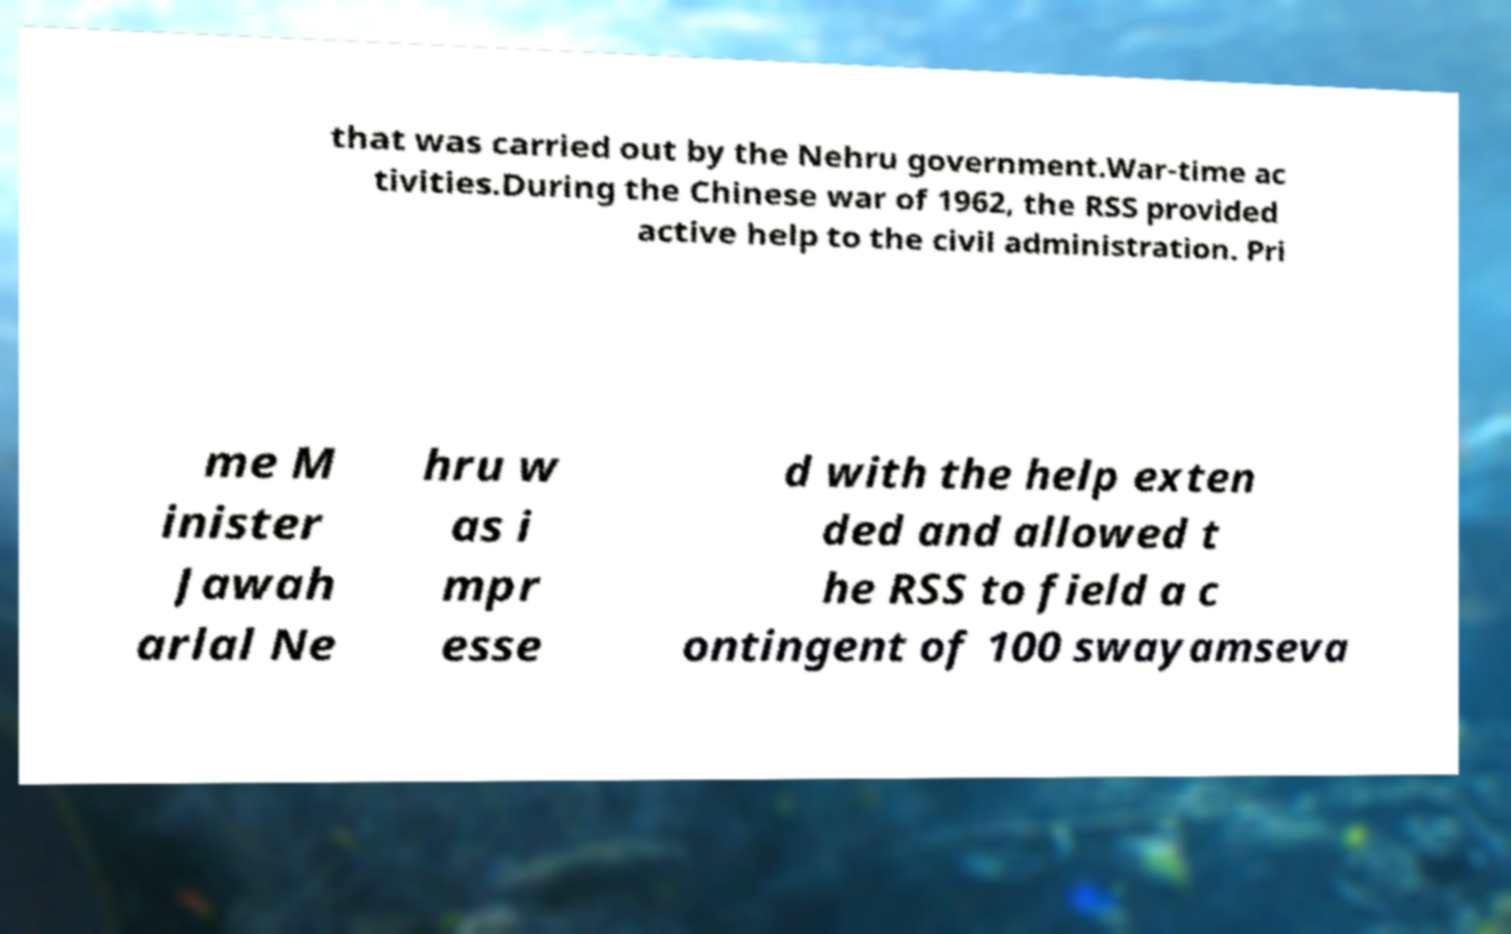Can you accurately transcribe the text from the provided image for me? that was carried out by the Nehru government.War-time ac tivities.During the Chinese war of 1962, the RSS provided active help to the civil administration. Pri me M inister Jawah arlal Ne hru w as i mpr esse d with the help exten ded and allowed t he RSS to field a c ontingent of 100 swayamseva 